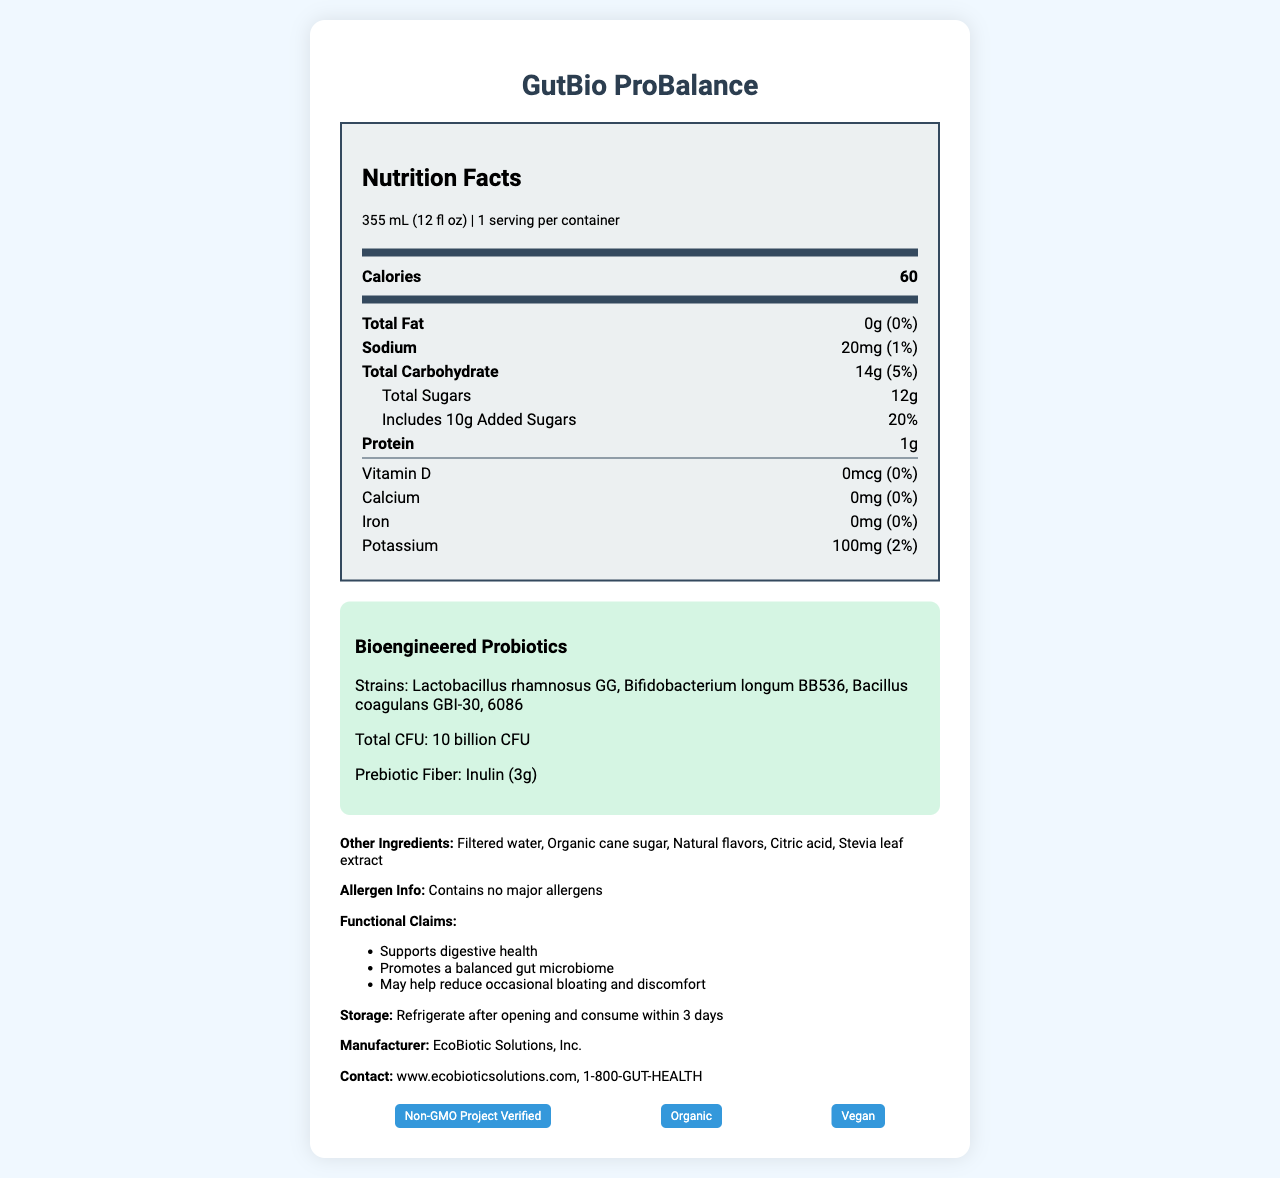How many calories are in one serving of GutBio ProBalance? The document specifies that there are 60 calories in a serving size of 355 mL (12 fl oz).
Answer: 60 What is the serving size of GutBio ProBalance? The serving size is clearly mentioned in the document as 355 mL (12 fl oz).
Answer: 355 mL (12 fl oz) List the bioengineered probiotic strains included in GutBio ProBalance. The document lists these strains under the section "Bioengineered Probiotics".
Answer: Lactobacillus rhamnosus GG, Bifidobacterium longum BB536, Bacillus coagulans GBI-30, 6086 What is the total carbohydrate content per serving? The document states the total carbohydrate content as 14g per serving.
Answer: 14g What is the daily value percentage for added sugars in one serving? The added sugars amount is 10g and the daily value percentage is listed as 20%.
Answer: 20% Does this beverage contain any major allergens? The document specifically states that the product contains no major allergens.
Answer: No What is the total CFU count for the bioengineered probiotics? The total CFU count for bioengineered probiotics is listed as 10 billion CFU.
Answer: 10 billion CFU What are the storage instructions for GutBio ProBalance? The document explicitly states the storage instructions.
Answer: Refrigerate after opening and consume within 3 days What is the vitamin D content in GutBio ProBalance? The vitamin D content is listed as 0mcg.
Answer: 0mcg Identify the company that manufactures GutBio ProBalance. The document provides the manufacturer's name as EcoBiotic Solutions, Inc.
Answer: EcoBiotic Solutions, Inc. Which of the following is NOT a functional claim made by GutBio ProBalance? A. Supports digestive health B. Enhances mental focus C. Promotes a balanced gut microbiome D. May help reduce occasional bloating and discomfort The document lists supporting digestive health, promoting a balanced gut microbiome, and possibly reducing occasional bloating and discomfort as functional claims, but not enhancing mental focus.
Answer: B. Enhances mental focus Which label certification does the product have? A. USDA Organic B. Fair Trade Certified C. Non-GMO Project Verified D. Gluten-Free The document lists "Non-GMO Project Verified" as one of the certifications of the product, but not USDA Organic, Fair Trade Certified, or Gluten-Free.
Answer: C. Non-GMO Project Verified Is the GutBio ProBalance a vegan product? The document lists "Vegan" as one of the certifications, indicating that the product is suitable for vegans.
Answer: Yes Summarize the main information provided in the GutBio ProBalance nutrition facts document. The document provides a comprehensive overview of GutBio ProBalance, covering nutritional content, probiotic strains, allergens, functional claims, certifications, and storage instructions.
Answer: GutBio ProBalance is a functional beverage designed to support gut health, containing bioengineered probiotics and prebiotic fiber. It has 60 calories per serving, minimal fat, sodium, and protein levels, but contains 14g of carbohydrates including 12g of sugars. The beverage also has certifications such as Non-GMO Project Verified, Organic, and Vegan, and includes specific strains of probiotics totaling 10 billion CFU. It must be refrigerated after opening and consumed within 3 days. What is the primary source of fiber in GutBio ProBalance? The document mentions that inulin is used as the prebiotic fiber, with an amount of 3g.
Answer: Inulin How many grams of protein does GutBio ProBalance contain per serving? The protein content per serving is listed as 1g in the document.
Answer: 1g Can you determine the flavor of GutBio ProBalance from this document? The document lists "Natural flavors" as an ingredient but does not specify the exact flavor of the beverage.
Answer: Cannot be determined 